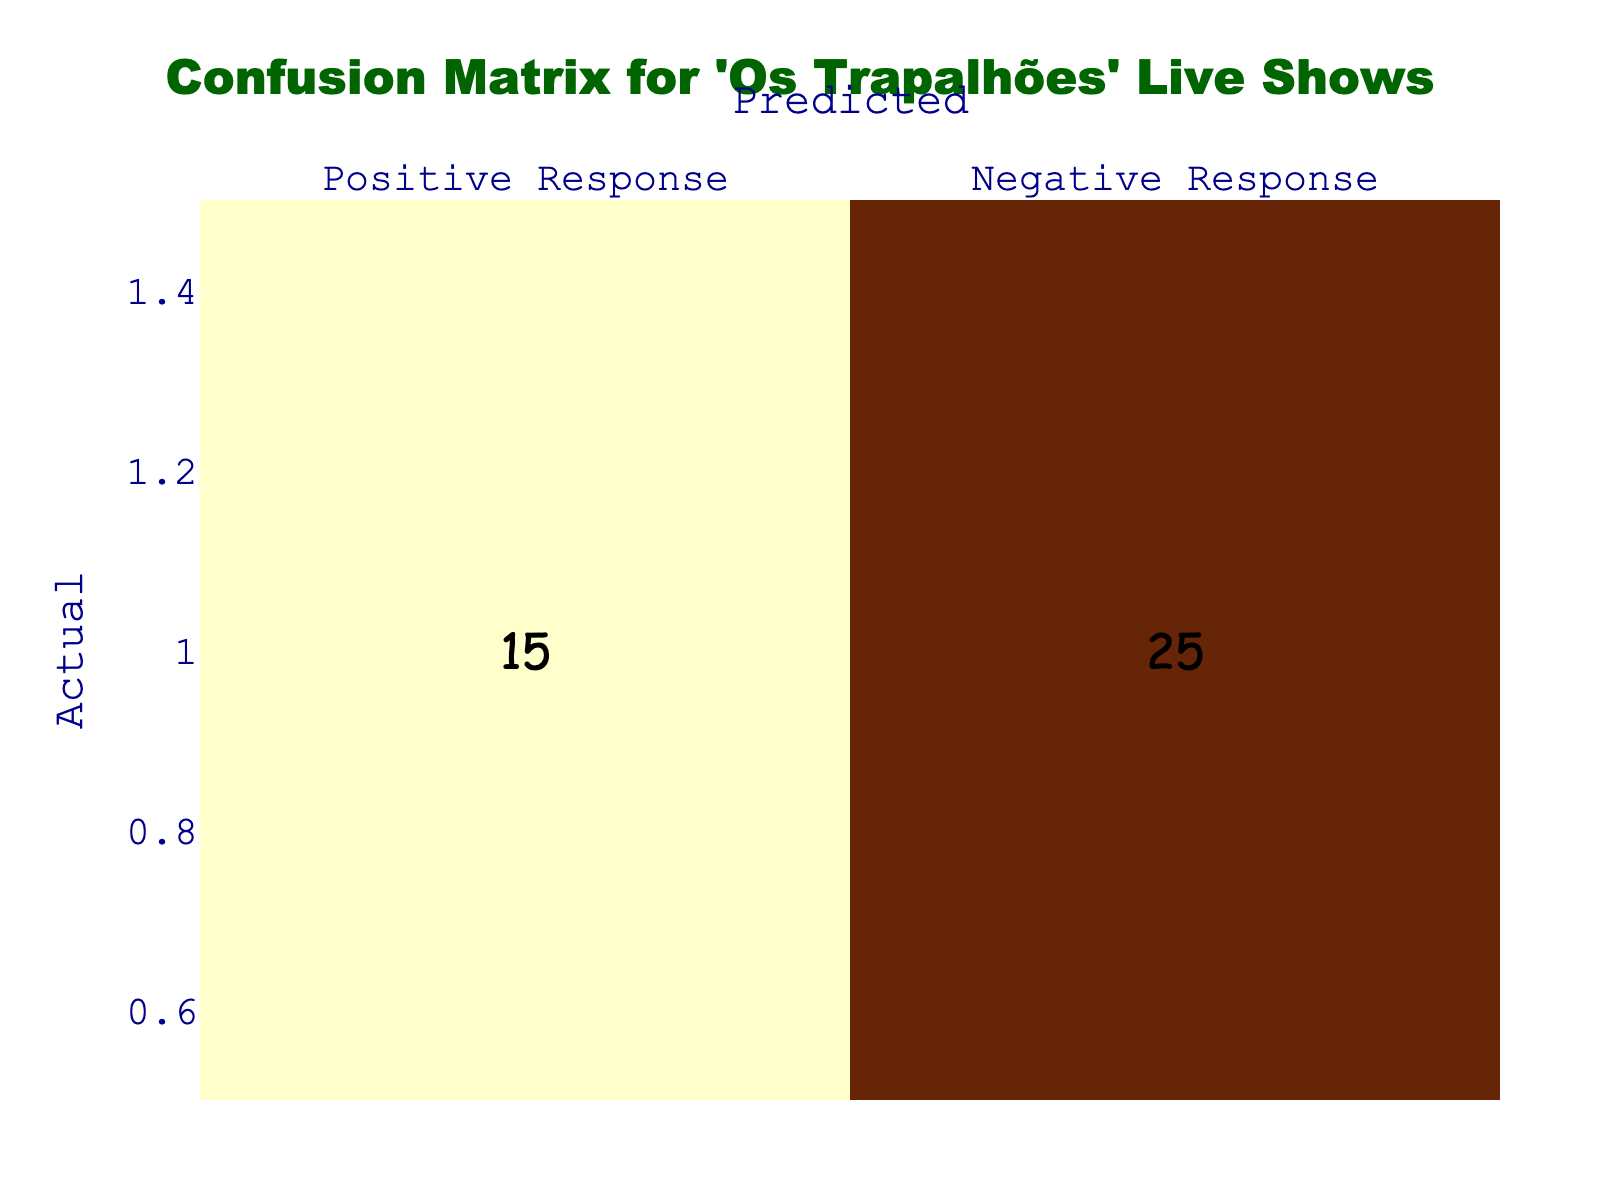What is the count of Positive Responses predicted correctly? The table shows that the count for "Positive Response" predicted as "Positive Response" is 80. This is directly taken from the cell corresponding to the actual "Positive Response" and predicted "Positive Response."
Answer: 80 What is the count of Negative Responses predicted correctly? The count for "Negative Response" predicted as "Negative Response" is 25, shown in the respective cell for "Negative Response" actual and predicted as "Negative Response."
Answer: 25 What is the count of actual Negative Responses that were predicted as Positive? The count of actual "Negative Response" predicted as "Positive Response" is 15, located in the row for actual "Negative Response" and the column for predicted "Positive Response."
Answer: 15 How many total Positive Responses were predicted? The total count of predicted Positive Responses is calculated by summing the counts in the "Positive Response" column: 80 (correctly predicted) + 10 (incorrectly predicted) = 90.
Answer: 90 What is the total count of actual Negative Responses? The total count of actual Negative Responses is found by adding the counts in the "Negative Response" row: 15 (predicted as Positive) + 25 (predicted as Negative) = 40.
Answer: 40 Are there more correct predictions for Positive Responses than Negative Responses? The correct prediction for Positive Responses is 80, while for Negative Responses it is 25. Since 80 is greater than 25, the answer is yes.
Answer: Yes Is the sum of True Positives and True Negatives greater than the sum of False Positives and False Negatives? True Positives (80) + True Negatives (25) = 105. False Positives (10) + False Negatives (15) = 25. Since 105 is greater than 25, the answer is yes.
Answer: Yes What is the difference between the incorrectly predicted Positive and Negative Responses? The incorrectly predicted Positive Responses are 10 and the incorrectly predicted Negative Responses are 15. The difference is 15 - 10 = 5.
Answer: 5 What percentage of actual Positive Responses were correctly predicted? To find the percentage, we take the count of correctly predicted Positive Responses (80) and divide it by the total actual Positive Responses (80 + 10 = 90), resulting in (80/90)*100 = 88.89%.
Answer: 88.89% What is the overall accuracy of the predictions? The overall accuracy is calculated by taking the sum of correct predictions (True Positives + True Negatives) and dividing it by the total predictions (Total actual Positive + Total actual Negative). This gives (80 + 25) / (90 + 40) = 105 / 130 = 0.8077 or 80.77%.
Answer: 80.77% 